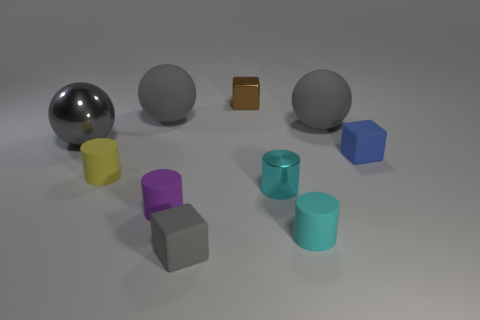Is there a thing made of the same material as the tiny gray cube?
Your response must be concise. Yes. There is a yellow object that is the same size as the blue object; what is it made of?
Provide a short and direct response. Rubber. How big is the gray matte thing that is both behind the gray rubber block and left of the cyan metal cylinder?
Your answer should be very brief. Large. There is a tiny rubber thing that is both behind the small cyan metallic thing and left of the tiny brown thing; what is its color?
Offer a very short reply. Yellow. Are there fewer metal blocks that are in front of the blue rubber block than large balls that are on the left side of the metallic cube?
Your answer should be compact. Yes. What number of other things are the same shape as the cyan metal object?
Offer a terse response. 3. What is the size of the cyan cylinder that is made of the same material as the tiny yellow cylinder?
Offer a very short reply. Small. There is a small object behind the rubber cube that is behind the small gray rubber thing; what is its color?
Give a very brief answer. Brown. Does the tiny brown metal object have the same shape as the tiny rubber thing behind the yellow matte thing?
Provide a succinct answer. Yes. What number of brown metal blocks are the same size as the metal cylinder?
Your answer should be compact. 1. 